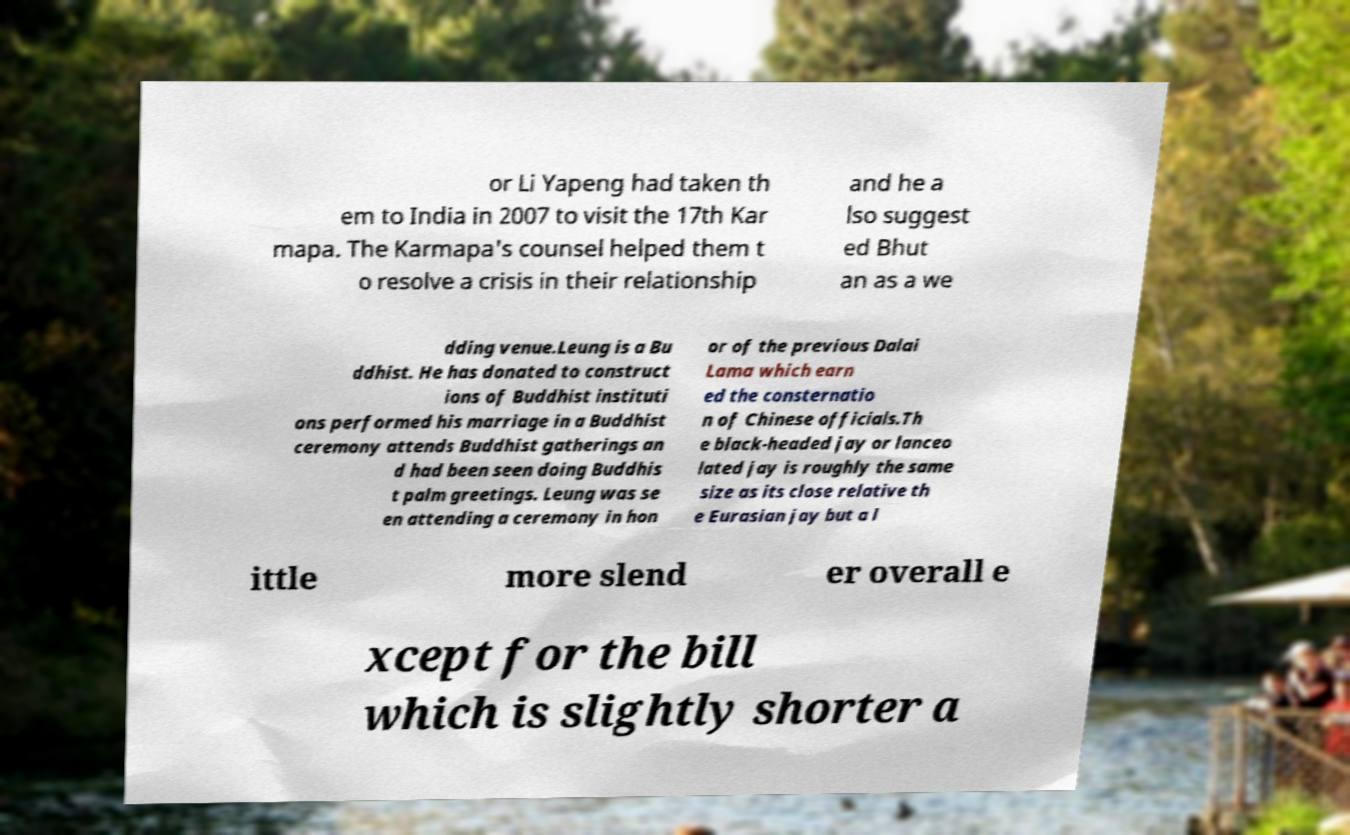Can you accurately transcribe the text from the provided image for me? or Li Yapeng had taken th em to India in 2007 to visit the 17th Kar mapa. The Karmapa's counsel helped them t o resolve a crisis in their relationship and he a lso suggest ed Bhut an as a we dding venue.Leung is a Bu ddhist. He has donated to construct ions of Buddhist instituti ons performed his marriage in a Buddhist ceremony attends Buddhist gatherings an d had been seen doing Buddhis t palm greetings. Leung was se en attending a ceremony in hon or of the previous Dalai Lama which earn ed the consternatio n of Chinese officials.Th e black-headed jay or lanceo lated jay is roughly the same size as its close relative th e Eurasian jay but a l ittle more slend er overall e xcept for the bill which is slightly shorter a 